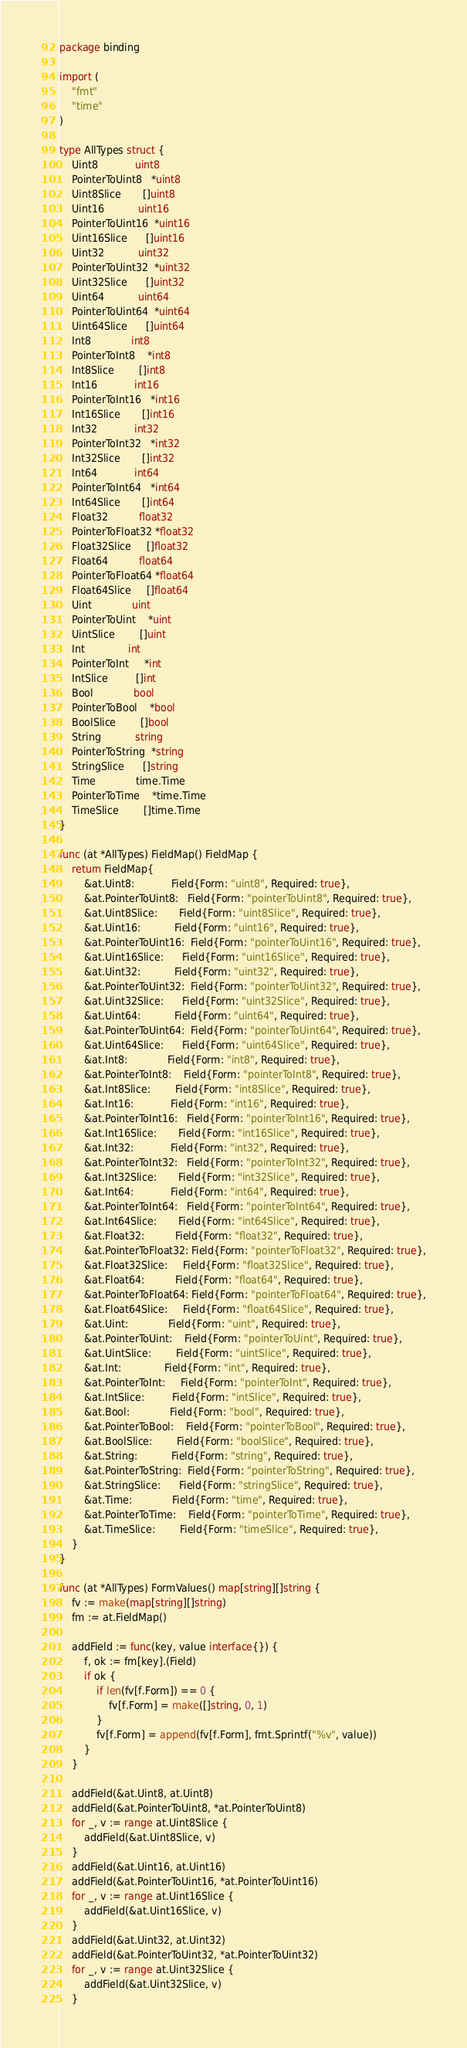Convert code to text. <code><loc_0><loc_0><loc_500><loc_500><_Go_>package binding

import (
	"fmt"
	"time"
)

type AllTypes struct {
	Uint8            uint8
	PointerToUint8   *uint8
	Uint8Slice       []uint8
	Uint16           uint16
	PointerToUint16  *uint16
	Uint16Slice      []uint16
	Uint32           uint32
	PointerToUint32  *uint32
	Uint32Slice      []uint32
	Uint64           uint64
	PointerToUint64  *uint64
	Uint64Slice      []uint64
	Int8             int8
	PointerToInt8    *int8
	Int8Slice        []int8
	Int16            int16
	PointerToInt16   *int16
	Int16Slice       []int16
	Int32            int32
	PointerToInt32   *int32
	Int32Slice       []int32
	Int64            int64
	PointerToInt64   *int64
	Int64Slice       []int64
	Float32          float32
	PointerToFloat32 *float32
	Float32Slice     []float32
	Float64          float64
	PointerToFloat64 *float64
	Float64Slice     []float64
	Uint             uint
	PointerToUint    *uint
	UintSlice        []uint
	Int              int
	PointerToInt     *int
	IntSlice         []int
	Bool             bool
	PointerToBool    *bool
	BoolSlice        []bool
	String           string
	PointerToString  *string
	StringSlice      []string
	Time             time.Time
	PointerToTime    *time.Time
	TimeSlice        []time.Time
}

func (at *AllTypes) FieldMap() FieldMap {
	return FieldMap{
		&at.Uint8:            Field{Form: "uint8", Required: true},
		&at.PointerToUint8:   Field{Form: "pointerToUint8", Required: true},
		&at.Uint8Slice:       Field{Form: "uint8Slice", Required: true},
		&at.Uint16:           Field{Form: "uint16", Required: true},
		&at.PointerToUint16:  Field{Form: "pointerToUint16", Required: true},
		&at.Uint16Slice:      Field{Form: "uint16Slice", Required: true},
		&at.Uint32:           Field{Form: "uint32", Required: true},
		&at.PointerToUint32:  Field{Form: "pointerToUint32", Required: true},
		&at.Uint32Slice:      Field{Form: "uint32Slice", Required: true},
		&at.Uint64:           Field{Form: "uint64", Required: true},
		&at.PointerToUint64:  Field{Form: "pointerToUint64", Required: true},
		&at.Uint64Slice:      Field{Form: "uint64Slice", Required: true},
		&at.Int8:             Field{Form: "int8", Required: true},
		&at.PointerToInt8:    Field{Form: "pointerToInt8", Required: true},
		&at.Int8Slice:        Field{Form: "int8Slice", Required: true},
		&at.Int16:            Field{Form: "int16", Required: true},
		&at.PointerToInt16:   Field{Form: "pointerToInt16", Required: true},
		&at.Int16Slice:       Field{Form: "int16Slice", Required: true},
		&at.Int32:            Field{Form: "int32", Required: true},
		&at.PointerToInt32:   Field{Form: "pointerToInt32", Required: true},
		&at.Int32Slice:       Field{Form: "int32Slice", Required: true},
		&at.Int64:            Field{Form: "int64", Required: true},
		&at.PointerToInt64:   Field{Form: "pointerToInt64", Required: true},
		&at.Int64Slice:       Field{Form: "int64Slice", Required: true},
		&at.Float32:          Field{Form: "float32", Required: true},
		&at.PointerToFloat32: Field{Form: "pointerToFloat32", Required: true},
		&at.Float32Slice:     Field{Form: "float32Slice", Required: true},
		&at.Float64:          Field{Form: "float64", Required: true},
		&at.PointerToFloat64: Field{Form: "pointerToFloat64", Required: true},
		&at.Float64Slice:     Field{Form: "float64Slice", Required: true},
		&at.Uint:             Field{Form: "uint", Required: true},
		&at.PointerToUint:    Field{Form: "pointerToUint", Required: true},
		&at.UintSlice:        Field{Form: "uintSlice", Required: true},
		&at.Int:              Field{Form: "int", Required: true},
		&at.PointerToInt:     Field{Form: "pointerToInt", Required: true},
		&at.IntSlice:         Field{Form: "intSlice", Required: true},
		&at.Bool:             Field{Form: "bool", Required: true},
		&at.PointerToBool:    Field{Form: "pointerToBool", Required: true},
		&at.BoolSlice:        Field{Form: "boolSlice", Required: true},
		&at.String:           Field{Form: "string", Required: true},
		&at.PointerToString:  Field{Form: "pointerToString", Required: true},
		&at.StringSlice:      Field{Form: "stringSlice", Required: true},
		&at.Time:             Field{Form: "time", Required: true},
		&at.PointerToTime:    Field{Form: "pointerToTime", Required: true},
		&at.TimeSlice:        Field{Form: "timeSlice", Required: true},
	}
}

func (at *AllTypes) FormValues() map[string][]string {
	fv := make(map[string][]string)
	fm := at.FieldMap()

	addField := func(key, value interface{}) {
		f, ok := fm[key].(Field)
		if ok {
			if len(fv[f.Form]) == 0 {
				fv[f.Form] = make([]string, 0, 1)
			}
			fv[f.Form] = append(fv[f.Form], fmt.Sprintf("%v", value))
		}
	}

	addField(&at.Uint8, at.Uint8)
	addField(&at.PointerToUint8, *at.PointerToUint8)
	for _, v := range at.Uint8Slice {
		addField(&at.Uint8Slice, v)
	}
	addField(&at.Uint16, at.Uint16)
	addField(&at.PointerToUint16, *at.PointerToUint16)
	for _, v := range at.Uint16Slice {
		addField(&at.Uint16Slice, v)
	}
	addField(&at.Uint32, at.Uint32)
	addField(&at.PointerToUint32, *at.PointerToUint32)
	for _, v := range at.Uint32Slice {
		addField(&at.Uint32Slice, v)
	}</code> 